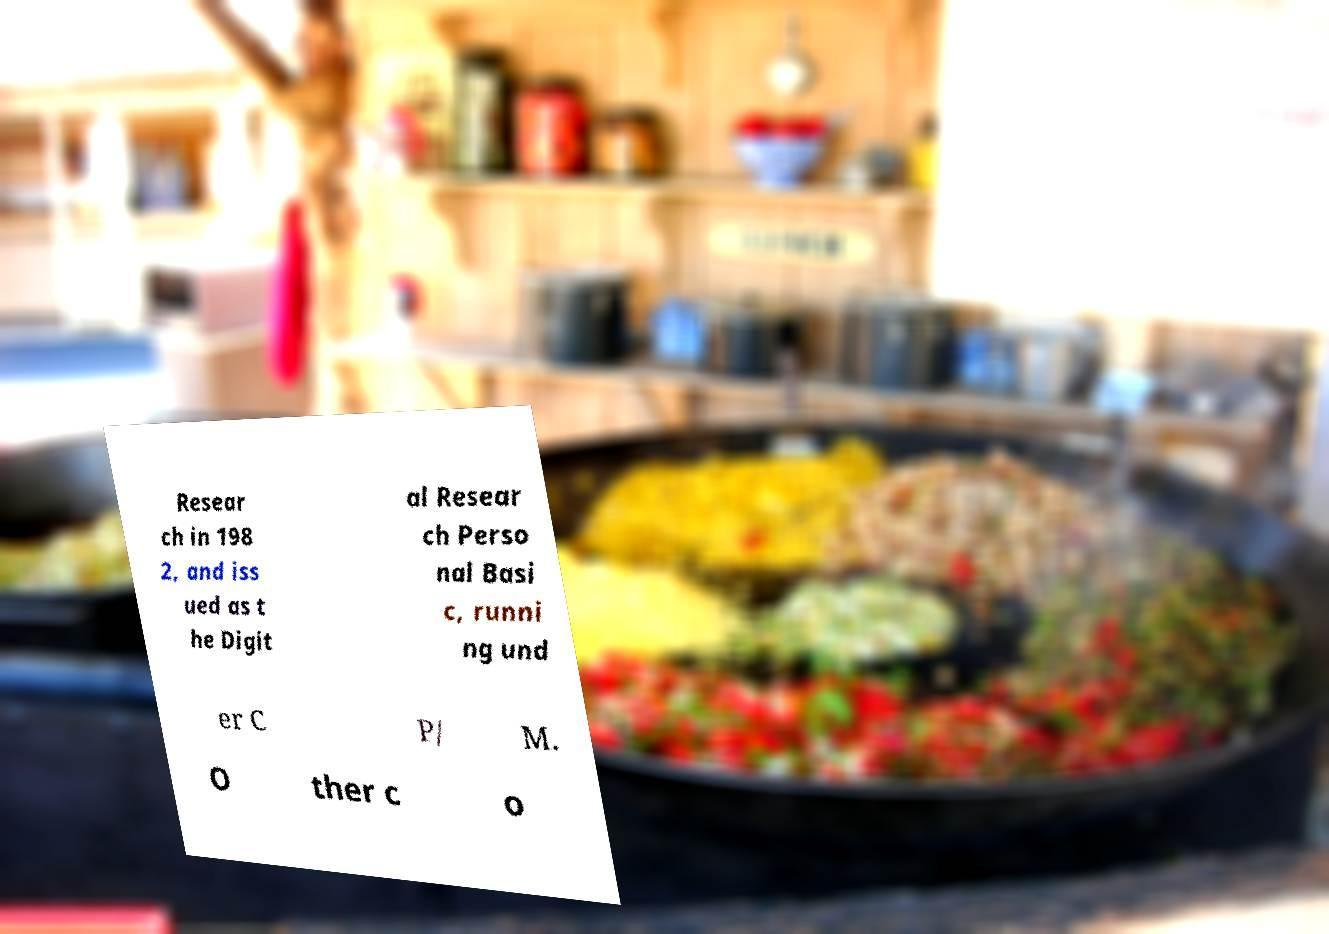What messages or text are displayed in this image? I need them in a readable, typed format. Resear ch in 198 2, and iss ued as t he Digit al Resear ch Perso nal Basi c, runni ng und er C P/ M. O ther c o 